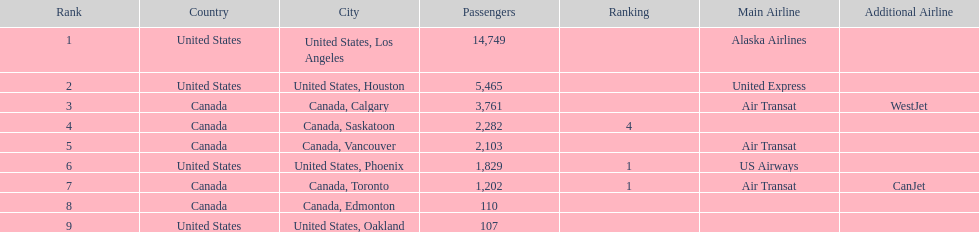Parse the full table. {'header': ['Rank', 'Country', 'City', 'Passengers', 'Ranking', 'Main Airline', 'Additional Airline'], 'rows': [['1', 'United States', 'United States, Los Angeles', '14,749', '', 'Alaska Airlines', ''], ['2', 'United States', 'United States, Houston', '5,465', '', 'United Express', ''], ['3', 'Canada', 'Canada, Calgary', '3,761', '', 'Air Transat', 'WestJet'], ['4', 'Canada', 'Canada, Saskatoon', '2,282', '4', '', ''], ['5', 'Canada', 'Canada, Vancouver', '2,103', '', 'Air Transat', ''], ['6', 'United States', 'United States, Phoenix', '1,829', '1', 'US Airways', ''], ['7', 'Canada', 'Canada, Toronto', '1,202', '1', 'Air Transat', 'CanJet'], ['8', 'Canada', 'Canada, Edmonton', '110', '', '', ''], ['9', 'United States', 'United States, Oakland', '107', '', '', '']]} Which canadian city had the most passengers traveling from manzanillo international airport in 2013? Calgary. 